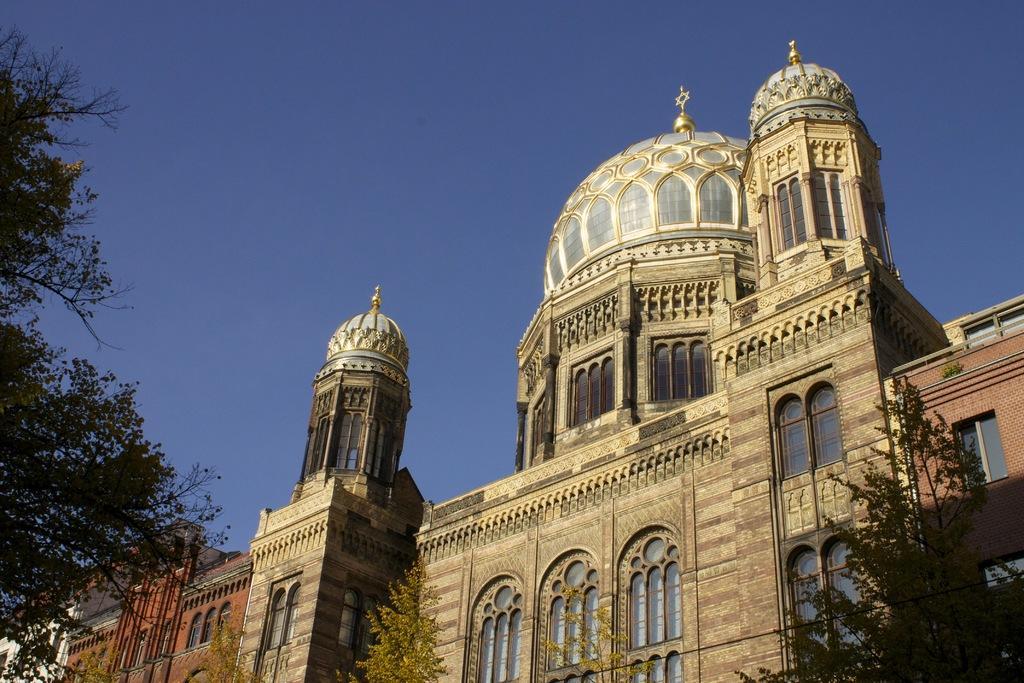Describe this image in one or two sentences. We can see trees and buildings. In the background we can see sky in blue color. 